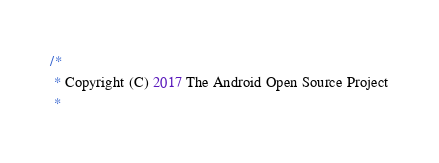<code> <loc_0><loc_0><loc_500><loc_500><_Java_>/*
 * Copyright (C) 2017 The Android Open Source Project
 *</code> 